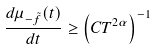<formula> <loc_0><loc_0><loc_500><loc_500>\frac { d \mu _ { - \tilde { f } } ( t ) } { d t } \geq \left ( C T ^ { 2 \alpha } \right ) ^ { - 1 }</formula> 